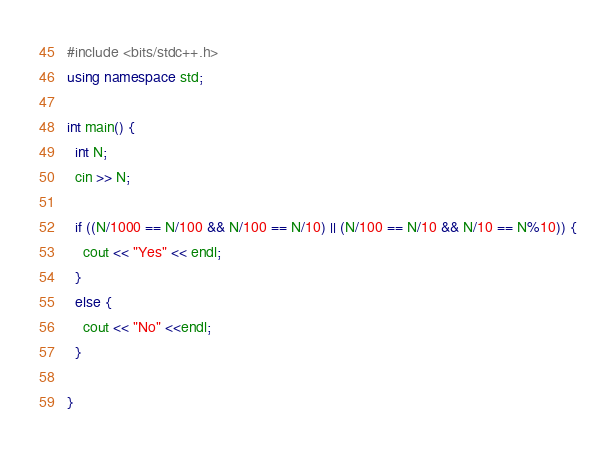<code> <loc_0><loc_0><loc_500><loc_500><_C++_>#include <bits/stdc++.h>
using namespace std;

int main() {
  int N;
  cin >> N;

  if ((N/1000 == N/100 && N/100 == N/10) || (N/100 == N/10 && N/10 == N%10)) {
    cout << "Yes" << endl;
  }
  else {
    cout << "No" <<endl;
  }

}
</code> 